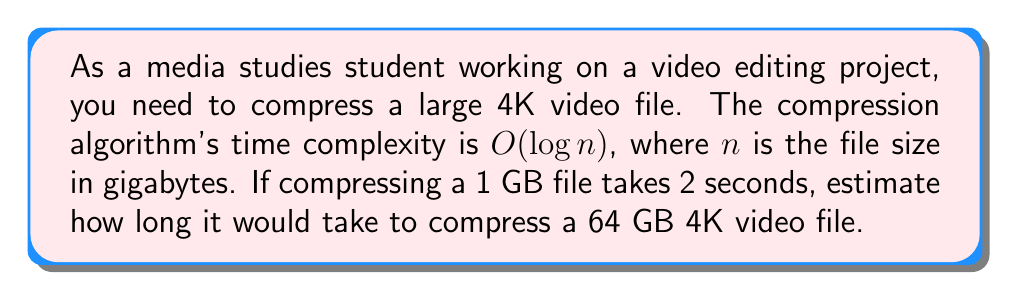Help me with this question. Let's approach this step-by-step:

1) The time complexity is $O(\log n)$, which means the time taken is proportional to the logarithm of the file size.

2) We're given that compressing a 1 GB file takes 2 seconds. Let's call the constant of proportionality $k$. So:

   $2 = k \log(1)$

   Since $\log(1) = 0$ for any base, this doesn't give us the value of $k$. We need to use the 64 GB file information.

3) Let $t$ be the time taken to compress the 64 GB file. Then:

   $t = k \log(64)$

4) We don't know $k$, but we can set up a proportion using the 1 GB file information:

   $\frac{2}{\log(1)} = \frac{t}{\log(64)}$

5) Simplify:
   
   $\frac{2}{0} = \frac{t}{6}$ (using $\log_2(64) = 6$)

6) Solve for $t$:

   $t = 2 \cdot \frac{6}{0} = 12$

Therefore, it would take approximately 12 seconds to compress the 64 GB file.
Answer: 12 seconds 